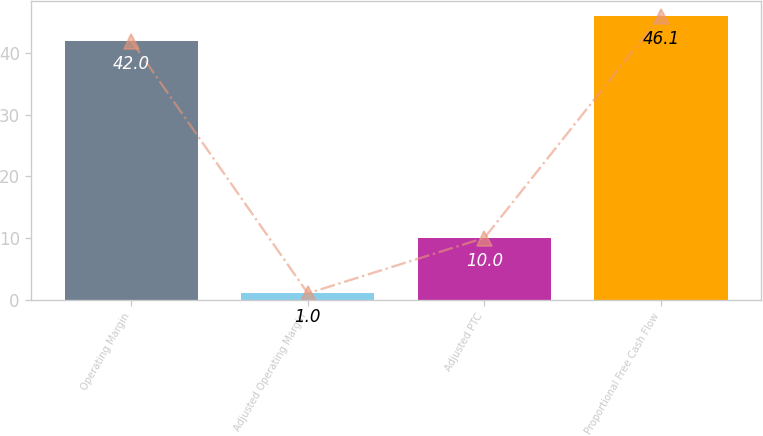<chart> <loc_0><loc_0><loc_500><loc_500><bar_chart><fcel>Operating Margin<fcel>Adjusted Operating Margin<fcel>Adjusted PTC<fcel>Proportional Free Cash Flow<nl><fcel>42<fcel>1<fcel>10<fcel>46.1<nl></chart> 